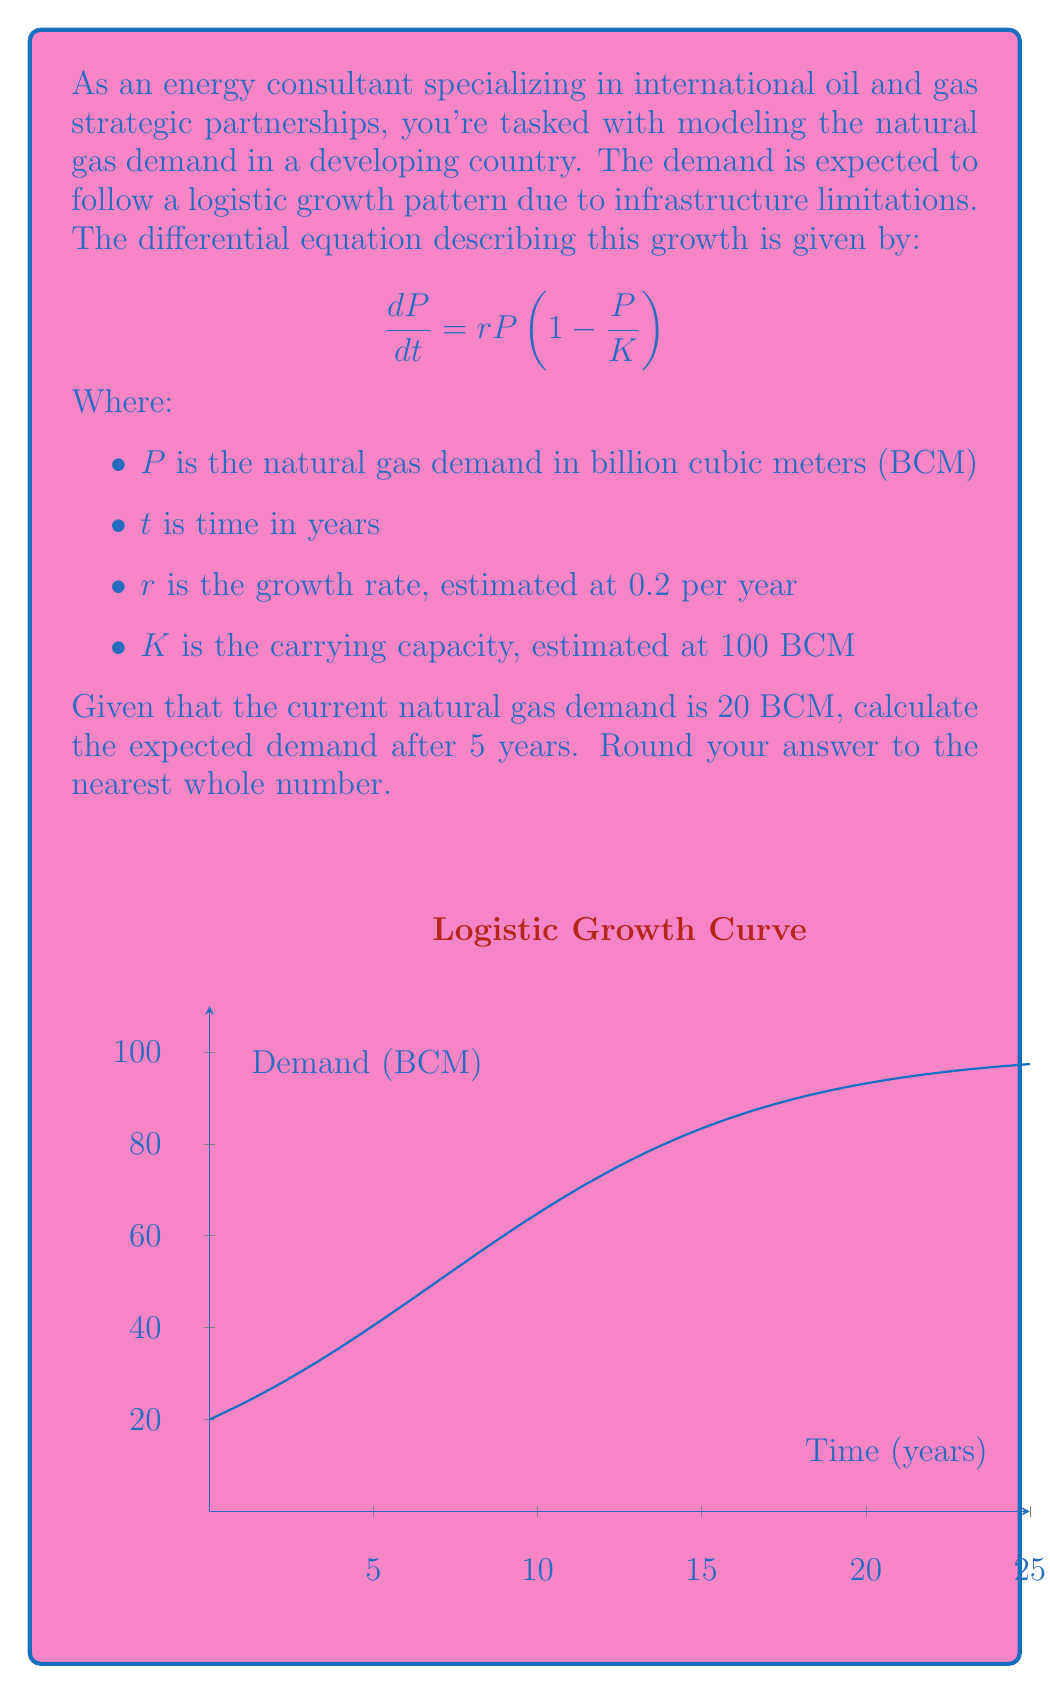Solve this math problem. To solve this problem, we need to use the solution to the logistic differential equation:

1) The general solution to the logistic differential equation is:

   $$P(t) = \frac{K}{1 + (\frac{K}{P_0} - 1)e^{-rt}}$$

   Where $P_0$ is the initial population (or in this case, initial demand).

2) We're given:
   - $K = 100$ BCM
   - $r = 0.2$ per year
   - $P_0 = 20$ BCM
   - $t = 5$ years

3) Let's substitute these values into our equation:

   $$P(5) = \frac{100}{1 + (\frac{100}{20} - 1)e^{-0.2(5)}}$$

4) Simplify:
   $$P(5) = \frac{100}{1 + (5 - 1)e^{-1}}$$
   $$P(5) = \frac{100}{1 + 4e^{-1}}$$

5) Calculate:
   $$P(5) = \frac{100}{1 + 4(0.3679)}$$
   $$P(5) = \frac{100}{2.4716}$$
   $$P(5) = 40.4597$$

6) Rounding to the nearest whole number:
   $$P(5) \approx 40$$ BCM
Answer: 40 BCM 